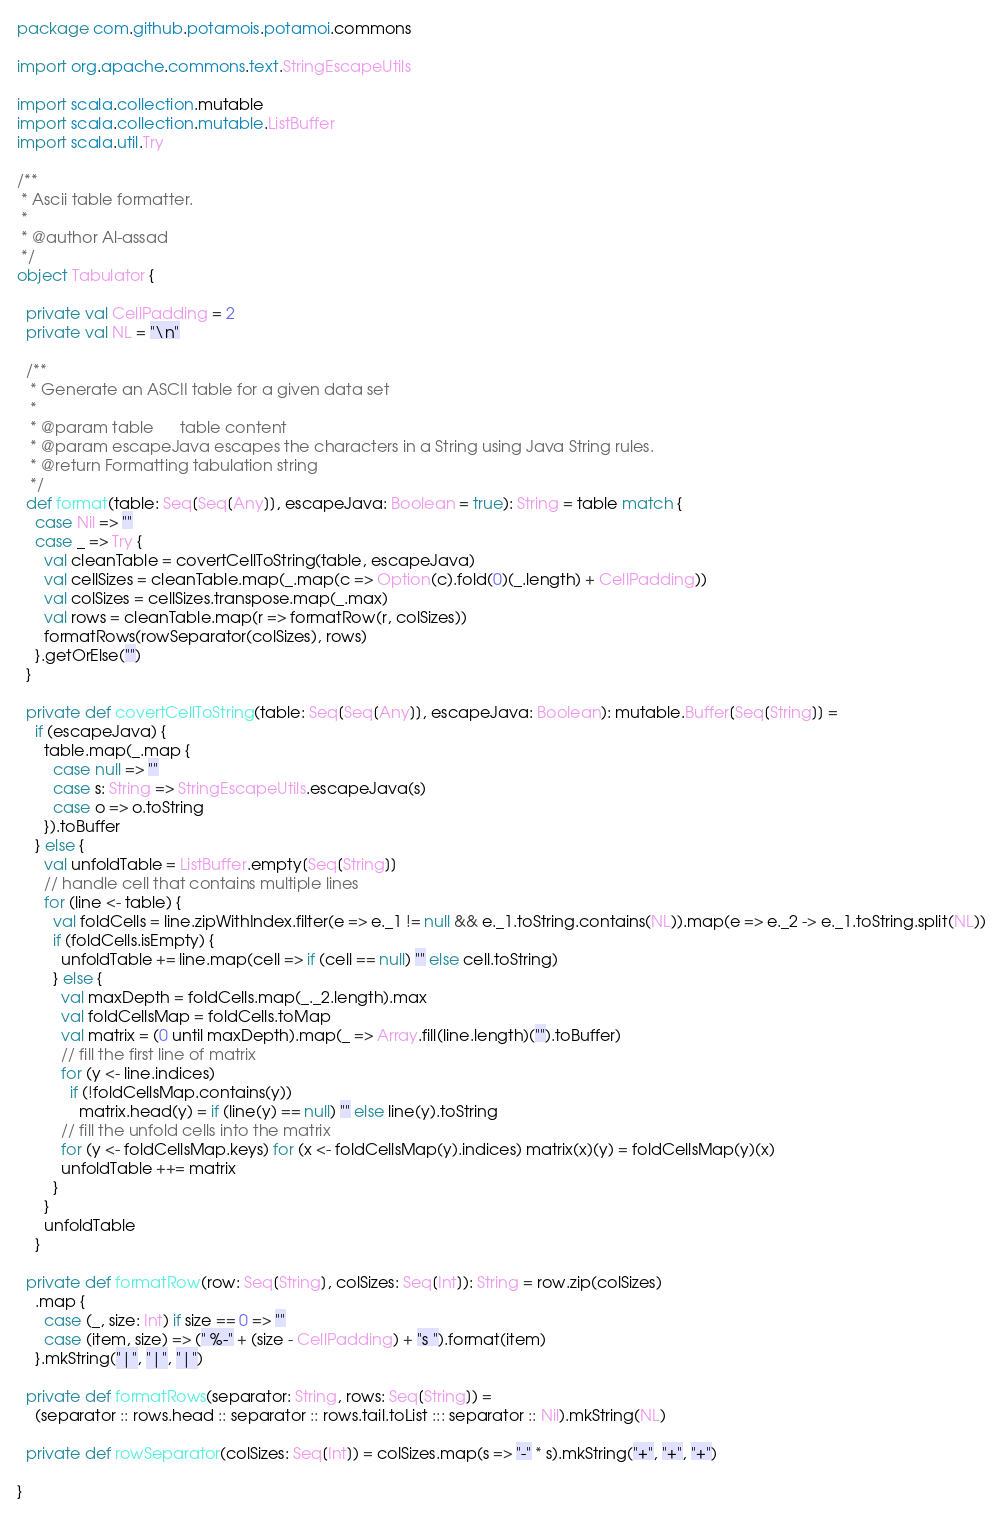Convert code to text. <code><loc_0><loc_0><loc_500><loc_500><_Scala_>package com.github.potamois.potamoi.commons

import org.apache.commons.text.StringEscapeUtils

import scala.collection.mutable
import scala.collection.mutable.ListBuffer
import scala.util.Try

/**
 * Ascii table formatter.
 *
 * @author Al-assad
 */
object Tabulator {

  private val CellPadding = 2
  private val NL = "\n"

  /**
   * Generate an ASCII table for a given data set
   *
   * @param table      table content
   * @param escapeJava escapes the characters in a String using Java String rules.
   * @return Formatting tabulation string
   */
  def format(table: Seq[Seq[Any]], escapeJava: Boolean = true): String = table match {
    case Nil => ""
    case _ => Try {
      val cleanTable = covertCellToString(table, escapeJava)
      val cellSizes = cleanTable.map(_.map(c => Option(c).fold(0)(_.length) + CellPadding))
      val colSizes = cellSizes.transpose.map(_.max)
      val rows = cleanTable.map(r => formatRow(r, colSizes))
      formatRows(rowSeparator(colSizes), rows)
    }.getOrElse("")
  }

  private def covertCellToString(table: Seq[Seq[Any]], escapeJava: Boolean): mutable.Buffer[Seq[String]] =
    if (escapeJava) {
      table.map(_.map {
        case null => ""
        case s: String => StringEscapeUtils.escapeJava(s)
        case o => o.toString
      }).toBuffer
    } else {
      val unfoldTable = ListBuffer.empty[Seq[String]]
      // handle cell that contains multiple lines
      for (line <- table) {
        val foldCells = line.zipWithIndex.filter(e => e._1 != null && e._1.toString.contains(NL)).map(e => e._2 -> e._1.toString.split(NL))
        if (foldCells.isEmpty) {
          unfoldTable += line.map(cell => if (cell == null) "" else cell.toString)
        } else {
          val maxDepth = foldCells.map(_._2.length).max
          val foldCellsMap = foldCells.toMap
          val matrix = (0 until maxDepth).map(_ => Array.fill(line.length)("").toBuffer)
          // fill the first line of matrix
          for (y <- line.indices)
            if (!foldCellsMap.contains(y))
              matrix.head(y) = if (line(y) == null) "" else line(y).toString
          // fill the unfold cells into the matrix
          for (y <- foldCellsMap.keys) for (x <- foldCellsMap(y).indices) matrix(x)(y) = foldCellsMap(y)(x)
          unfoldTable ++= matrix
        }
      }
      unfoldTable
    }

  private def formatRow(row: Seq[String], colSizes: Seq[Int]): String = row.zip(colSizes)
    .map {
      case (_, size: Int) if size == 0 => ""
      case (item, size) => (" %-" + (size - CellPadding) + "s ").format(item)
    }.mkString("|", "|", "|")

  private def formatRows(separator: String, rows: Seq[String]) =
    (separator :: rows.head :: separator :: rows.tail.toList ::: separator :: Nil).mkString(NL)

  private def rowSeparator(colSizes: Seq[Int]) = colSizes.map(s => "-" * s).mkString("+", "+", "+")

}

</code> 